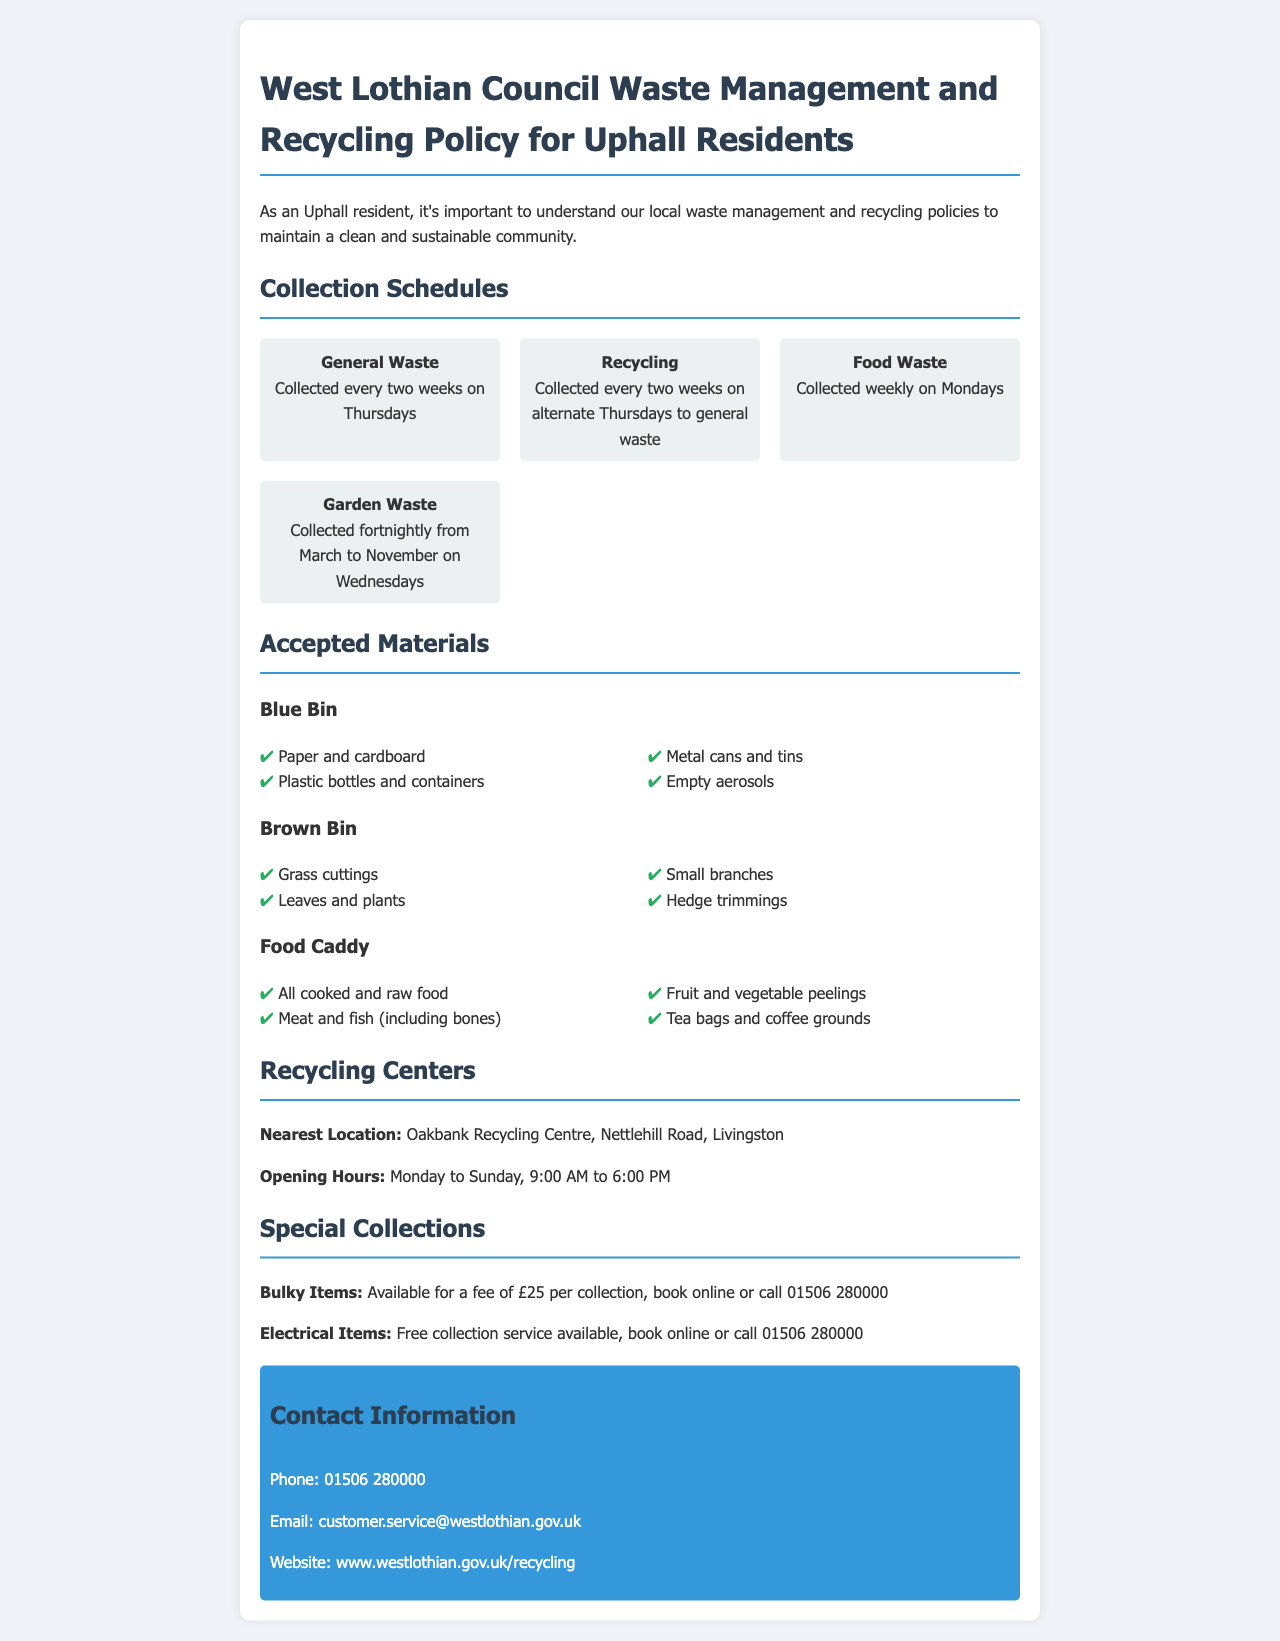What day is general waste collected? General waste is collected every two weeks on Thursdays, as stated in the collection schedules.
Answer: Thursdays How often is food waste collected? Food waste is collected weekly on Mondays according to the schedule provided.
Answer: Weekly What materials can be placed in the blue bin? The blue bin accepts paper and cardboard, plastic bottles and containers, metal cans and tins, and empty aerosols, as listed under accepted materials.
Answer: Paper and cardboard, plastic bottles and containers, metal cans and tins, empty aerosols When is garden waste collected? Garden waste is collected fortnightly from March to November on Wednesdays. This is indicated in the collection schedules.
Answer: Fortnightly from March to November on Wednesdays Where is the nearest recycling center located? The nearest recycling center is Oakbank Recycling Centre, located on Nettlehill Road, Livingston as specified in the document.
Answer: Oakbank Recycling Centre, Nettlehill Road, Livingston What is the fee for bulky item collection? The fee for bulky item collection is stated as £25 per collection in the special collections section.
Answer: £25 Which day is recycling collected? Recycling is collected every two weeks on alternate Thursdays to general waste, as detailed in the document.
Answer: Alternate Thursdays What can be disposed of in the food caddy? The food caddy accepts all cooked and raw food, meat and fish (including bones), fruit and vegetable peelings, tea bags and coffee grounds as mentioned in the accepted materials.
Answer: All cooked and raw food, meat and fish (including bones), fruit and vegetable peelings, tea bags and coffee grounds What is the contact phone number for customer service? The contact phone number provided for customer service is 01506 280000, as found in the contact information section.
Answer: 01506 280000 